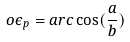Convert formula to latex. <formula><loc_0><loc_0><loc_500><loc_500>o \epsilon _ { p } = a r c \cos ( \frac { a } { b } )</formula> 